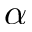Convert formula to latex. <formula><loc_0><loc_0><loc_500><loc_500>\alpha</formula> 